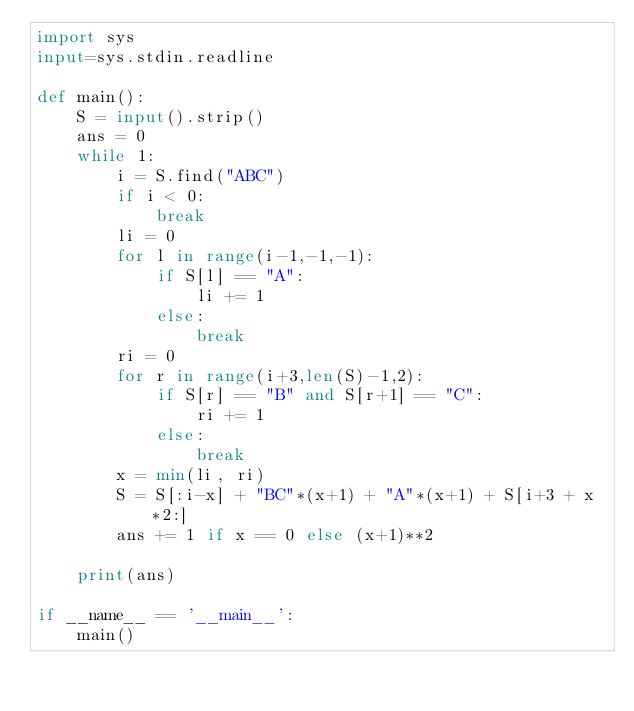Convert code to text. <code><loc_0><loc_0><loc_500><loc_500><_Python_>import sys
input=sys.stdin.readline

def main():
    S = input().strip()
    ans = 0
    while 1:
        i = S.find("ABC")
        if i < 0:
            break
        li = 0
        for l in range(i-1,-1,-1):
            if S[l] == "A":
                li += 1
            else:
                break
        ri = 0
        for r in range(i+3,len(S)-1,2):
            if S[r] == "B" and S[r+1] == "C":
                ri += 1
            else:
                break
        x = min(li, ri)
        S = S[:i-x] + "BC"*(x+1) + "A"*(x+1) + S[i+3 + x*2:]
        ans += 1 if x == 0 else (x+1)**2
        
    print(ans)

if __name__ == '__main__':
    main()
</code> 